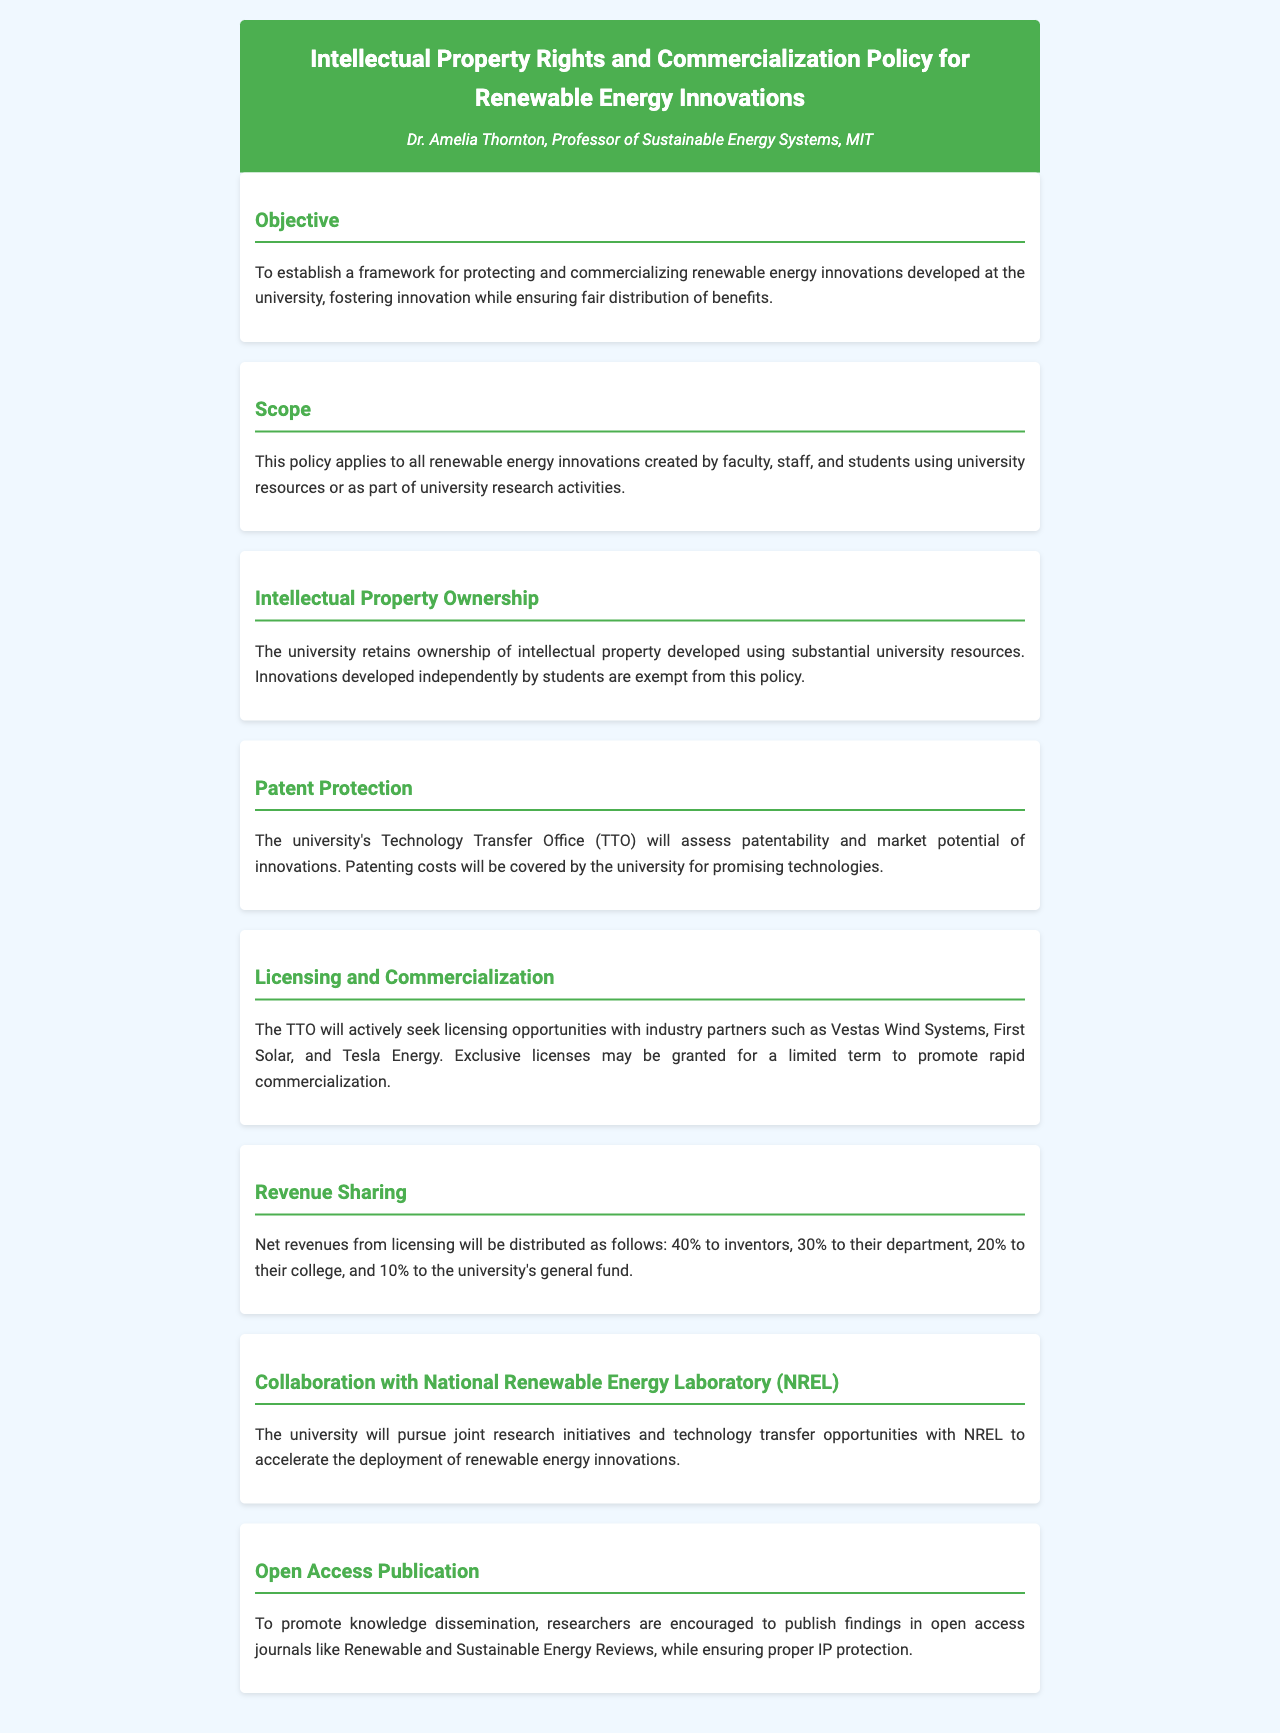What is the title of the policy document? The title is stated at the beginning of the document and reflects the focus on intellectual property rights in renewable energy innovations.
Answer: Intellectual Property Rights and Commercialization Policy for Renewable Energy Innovations Who authored the policy document? The author is mentioned in the header section of the document as the person responsible for this policy.
Answer: Dr. Amelia Thornton What percentage of net revenues is allocated to inventors? The revenue sharing section of the document specifies the percentage attributed to inventors within the net revenues from licensing.
Answer: 40% What does the university's Technology Transfer Office assess? The patent protection section outlines the responsibilities of the TTO, including evaluation tasks.
Answer: Patentability and market potential Which companies are mentioned as industry partners in the commercialization section? Specific companies are named as targets for licensing opportunities in the licensing and commercialization section.
Answer: Vestas Wind Systems, First Solar, and Tesla Energy What is the university's role in patenting costs? The document specifies the university's financial responsibility regarding patenting costs for certain innovations.
Answer: Covered by the university What is the primary objective of the policy? The objective section outlines the main goal of the document in relation to innovation and benefit distribution.
Answer: Protecting and commercializing renewable energy innovations What will the university pursue with the National Renewable Energy Laboratory? The collaboration section highlights the type of interactions and the intent behind working with NREL.
Answer: Joint research initiatives and technology transfer opportunities In which type of journals are researchers encouraged to publish? The open access publication section suggests specific outlets for disseminating research findings while adhering to the policy's guidelines.
Answer: Open access journals like Renewable and Sustainable Energy Reviews 